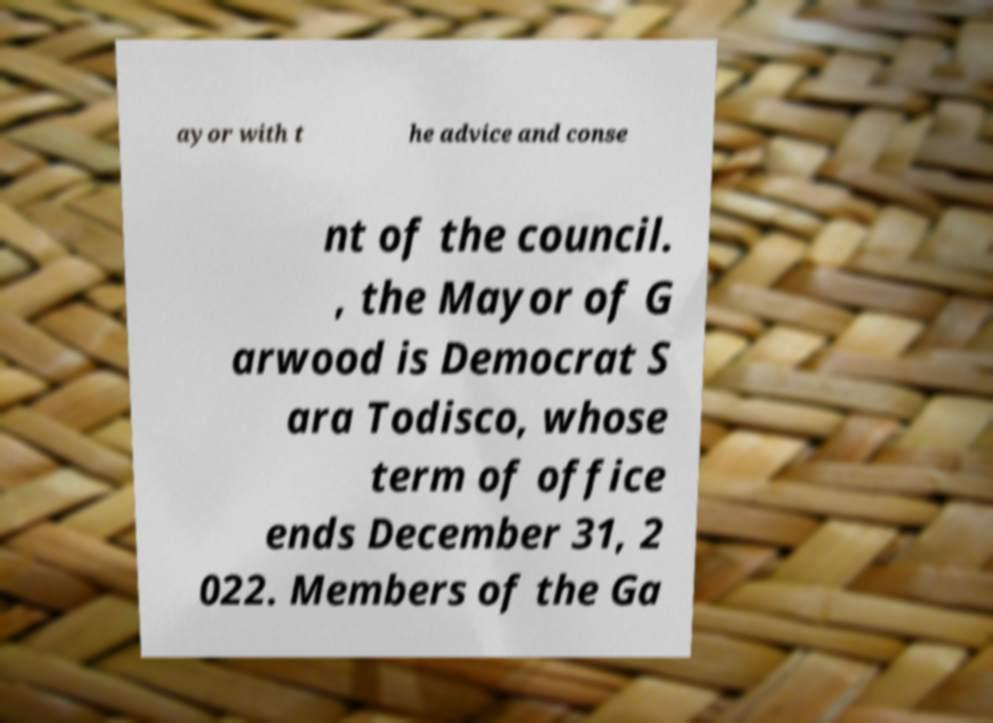Can you accurately transcribe the text from the provided image for me? ayor with t he advice and conse nt of the council. , the Mayor of G arwood is Democrat S ara Todisco, whose term of office ends December 31, 2 022. Members of the Ga 